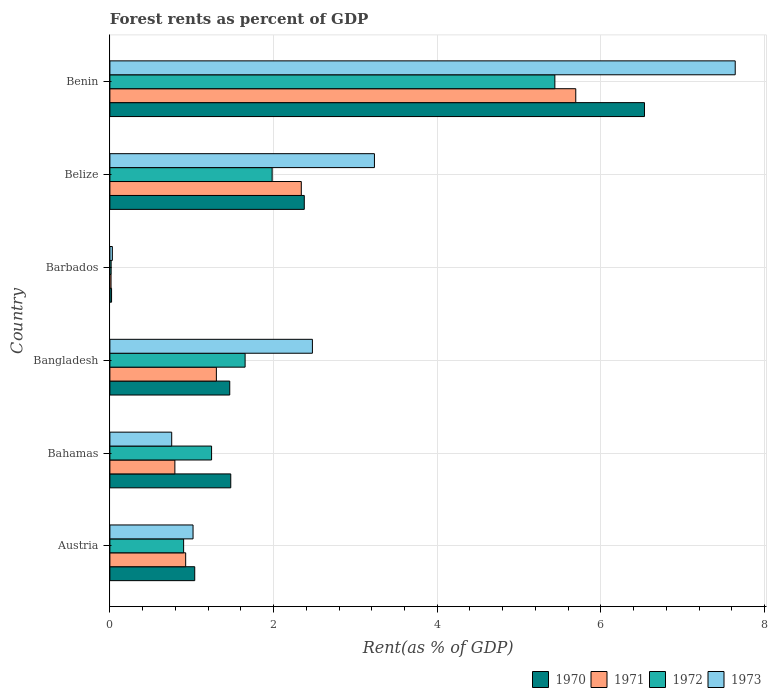How many different coloured bars are there?
Your answer should be compact. 4. Are the number of bars per tick equal to the number of legend labels?
Ensure brevity in your answer.  Yes. Are the number of bars on each tick of the Y-axis equal?
Ensure brevity in your answer.  Yes. What is the label of the 5th group of bars from the top?
Your answer should be compact. Bahamas. In how many cases, is the number of bars for a given country not equal to the number of legend labels?
Provide a short and direct response. 0. What is the forest rent in 1971 in Austria?
Your answer should be very brief. 0.93. Across all countries, what is the maximum forest rent in 1972?
Make the answer very short. 5.44. Across all countries, what is the minimum forest rent in 1972?
Offer a very short reply. 0.02. In which country was the forest rent in 1973 maximum?
Give a very brief answer. Benin. In which country was the forest rent in 1970 minimum?
Offer a terse response. Barbados. What is the total forest rent in 1970 in the graph?
Offer a very short reply. 12.91. What is the difference between the forest rent in 1973 in Austria and that in Bangladesh?
Provide a short and direct response. -1.46. What is the difference between the forest rent in 1973 in Austria and the forest rent in 1972 in Barbados?
Your response must be concise. 1. What is the average forest rent in 1973 per country?
Make the answer very short. 2.52. What is the difference between the forest rent in 1970 and forest rent in 1972 in Bahamas?
Make the answer very short. 0.23. In how many countries, is the forest rent in 1973 greater than 2.4 %?
Ensure brevity in your answer.  3. What is the ratio of the forest rent in 1972 in Barbados to that in Belize?
Ensure brevity in your answer.  0.01. Is the forest rent in 1972 in Bahamas less than that in Bangladesh?
Your response must be concise. Yes. What is the difference between the highest and the second highest forest rent in 1970?
Your answer should be very brief. 4.16. What is the difference between the highest and the lowest forest rent in 1970?
Offer a terse response. 6.51. Is the sum of the forest rent in 1971 in Bangladesh and Barbados greater than the maximum forest rent in 1970 across all countries?
Give a very brief answer. No. Is it the case that in every country, the sum of the forest rent in 1973 and forest rent in 1971 is greater than the sum of forest rent in 1970 and forest rent in 1972?
Give a very brief answer. No. How many countries are there in the graph?
Your response must be concise. 6. Where does the legend appear in the graph?
Provide a short and direct response. Bottom right. How many legend labels are there?
Keep it short and to the point. 4. How are the legend labels stacked?
Offer a very short reply. Horizontal. What is the title of the graph?
Your response must be concise. Forest rents as percent of GDP. What is the label or title of the X-axis?
Ensure brevity in your answer.  Rent(as % of GDP). What is the Rent(as % of GDP) in 1970 in Austria?
Provide a succinct answer. 1.04. What is the Rent(as % of GDP) of 1971 in Austria?
Keep it short and to the point. 0.93. What is the Rent(as % of GDP) of 1972 in Austria?
Provide a succinct answer. 0.9. What is the Rent(as % of GDP) of 1973 in Austria?
Offer a very short reply. 1.02. What is the Rent(as % of GDP) in 1970 in Bahamas?
Provide a short and direct response. 1.48. What is the Rent(as % of GDP) of 1971 in Bahamas?
Ensure brevity in your answer.  0.79. What is the Rent(as % of GDP) of 1972 in Bahamas?
Your response must be concise. 1.24. What is the Rent(as % of GDP) of 1973 in Bahamas?
Your response must be concise. 0.76. What is the Rent(as % of GDP) in 1970 in Bangladesh?
Make the answer very short. 1.46. What is the Rent(as % of GDP) in 1971 in Bangladesh?
Keep it short and to the point. 1.3. What is the Rent(as % of GDP) in 1972 in Bangladesh?
Give a very brief answer. 1.65. What is the Rent(as % of GDP) of 1973 in Bangladesh?
Your answer should be compact. 2.47. What is the Rent(as % of GDP) in 1970 in Barbados?
Offer a very short reply. 0.02. What is the Rent(as % of GDP) of 1971 in Barbados?
Make the answer very short. 0.01. What is the Rent(as % of GDP) of 1972 in Barbados?
Offer a very short reply. 0.02. What is the Rent(as % of GDP) of 1973 in Barbados?
Provide a succinct answer. 0.03. What is the Rent(as % of GDP) in 1970 in Belize?
Ensure brevity in your answer.  2.38. What is the Rent(as % of GDP) of 1971 in Belize?
Your answer should be very brief. 2.34. What is the Rent(as % of GDP) in 1972 in Belize?
Offer a very short reply. 1.98. What is the Rent(as % of GDP) in 1973 in Belize?
Give a very brief answer. 3.23. What is the Rent(as % of GDP) in 1970 in Benin?
Offer a terse response. 6.53. What is the Rent(as % of GDP) in 1971 in Benin?
Offer a very short reply. 5.69. What is the Rent(as % of GDP) in 1972 in Benin?
Offer a terse response. 5.44. What is the Rent(as % of GDP) in 1973 in Benin?
Keep it short and to the point. 7.64. Across all countries, what is the maximum Rent(as % of GDP) of 1970?
Provide a succinct answer. 6.53. Across all countries, what is the maximum Rent(as % of GDP) in 1971?
Your answer should be very brief. 5.69. Across all countries, what is the maximum Rent(as % of GDP) of 1972?
Keep it short and to the point. 5.44. Across all countries, what is the maximum Rent(as % of GDP) in 1973?
Your answer should be compact. 7.64. Across all countries, what is the minimum Rent(as % of GDP) of 1970?
Ensure brevity in your answer.  0.02. Across all countries, what is the minimum Rent(as % of GDP) of 1971?
Make the answer very short. 0.01. Across all countries, what is the minimum Rent(as % of GDP) of 1972?
Your response must be concise. 0.02. Across all countries, what is the minimum Rent(as % of GDP) in 1973?
Ensure brevity in your answer.  0.03. What is the total Rent(as % of GDP) in 1970 in the graph?
Give a very brief answer. 12.91. What is the total Rent(as % of GDP) of 1971 in the graph?
Give a very brief answer. 11.07. What is the total Rent(as % of GDP) of 1972 in the graph?
Ensure brevity in your answer.  11.23. What is the total Rent(as % of GDP) of 1973 in the graph?
Keep it short and to the point. 15.15. What is the difference between the Rent(as % of GDP) in 1970 in Austria and that in Bahamas?
Give a very brief answer. -0.44. What is the difference between the Rent(as % of GDP) of 1971 in Austria and that in Bahamas?
Provide a short and direct response. 0.13. What is the difference between the Rent(as % of GDP) in 1972 in Austria and that in Bahamas?
Provide a short and direct response. -0.34. What is the difference between the Rent(as % of GDP) in 1973 in Austria and that in Bahamas?
Your answer should be very brief. 0.26. What is the difference between the Rent(as % of GDP) in 1970 in Austria and that in Bangladesh?
Keep it short and to the point. -0.43. What is the difference between the Rent(as % of GDP) of 1971 in Austria and that in Bangladesh?
Provide a succinct answer. -0.38. What is the difference between the Rent(as % of GDP) in 1972 in Austria and that in Bangladesh?
Provide a short and direct response. -0.75. What is the difference between the Rent(as % of GDP) in 1973 in Austria and that in Bangladesh?
Ensure brevity in your answer.  -1.46. What is the difference between the Rent(as % of GDP) in 1970 in Austria and that in Barbados?
Offer a very short reply. 1.02. What is the difference between the Rent(as % of GDP) of 1971 in Austria and that in Barbados?
Your answer should be very brief. 0.91. What is the difference between the Rent(as % of GDP) of 1972 in Austria and that in Barbados?
Keep it short and to the point. 0.89. What is the difference between the Rent(as % of GDP) of 1973 in Austria and that in Barbados?
Provide a short and direct response. 0.99. What is the difference between the Rent(as % of GDP) in 1970 in Austria and that in Belize?
Keep it short and to the point. -1.34. What is the difference between the Rent(as % of GDP) of 1971 in Austria and that in Belize?
Provide a short and direct response. -1.41. What is the difference between the Rent(as % of GDP) of 1972 in Austria and that in Belize?
Give a very brief answer. -1.08. What is the difference between the Rent(as % of GDP) of 1973 in Austria and that in Belize?
Offer a terse response. -2.22. What is the difference between the Rent(as % of GDP) in 1970 in Austria and that in Benin?
Offer a very short reply. -5.5. What is the difference between the Rent(as % of GDP) in 1971 in Austria and that in Benin?
Make the answer very short. -4.77. What is the difference between the Rent(as % of GDP) in 1972 in Austria and that in Benin?
Ensure brevity in your answer.  -4.54. What is the difference between the Rent(as % of GDP) of 1973 in Austria and that in Benin?
Keep it short and to the point. -6.62. What is the difference between the Rent(as % of GDP) of 1970 in Bahamas and that in Bangladesh?
Give a very brief answer. 0.01. What is the difference between the Rent(as % of GDP) in 1971 in Bahamas and that in Bangladesh?
Offer a terse response. -0.51. What is the difference between the Rent(as % of GDP) in 1972 in Bahamas and that in Bangladesh?
Ensure brevity in your answer.  -0.41. What is the difference between the Rent(as % of GDP) in 1973 in Bahamas and that in Bangladesh?
Give a very brief answer. -1.72. What is the difference between the Rent(as % of GDP) in 1970 in Bahamas and that in Barbados?
Ensure brevity in your answer.  1.46. What is the difference between the Rent(as % of GDP) in 1971 in Bahamas and that in Barbados?
Give a very brief answer. 0.78. What is the difference between the Rent(as % of GDP) in 1972 in Bahamas and that in Barbados?
Ensure brevity in your answer.  1.23. What is the difference between the Rent(as % of GDP) in 1973 in Bahamas and that in Barbados?
Make the answer very short. 0.73. What is the difference between the Rent(as % of GDP) in 1970 in Bahamas and that in Belize?
Offer a very short reply. -0.9. What is the difference between the Rent(as % of GDP) in 1971 in Bahamas and that in Belize?
Keep it short and to the point. -1.54. What is the difference between the Rent(as % of GDP) in 1972 in Bahamas and that in Belize?
Give a very brief answer. -0.74. What is the difference between the Rent(as % of GDP) in 1973 in Bahamas and that in Belize?
Provide a succinct answer. -2.48. What is the difference between the Rent(as % of GDP) in 1970 in Bahamas and that in Benin?
Provide a short and direct response. -5.06. What is the difference between the Rent(as % of GDP) in 1971 in Bahamas and that in Benin?
Your answer should be very brief. -4.9. What is the difference between the Rent(as % of GDP) in 1972 in Bahamas and that in Benin?
Your response must be concise. -4.19. What is the difference between the Rent(as % of GDP) of 1973 in Bahamas and that in Benin?
Ensure brevity in your answer.  -6.89. What is the difference between the Rent(as % of GDP) in 1970 in Bangladesh and that in Barbados?
Offer a very short reply. 1.44. What is the difference between the Rent(as % of GDP) of 1971 in Bangladesh and that in Barbados?
Ensure brevity in your answer.  1.29. What is the difference between the Rent(as % of GDP) of 1972 in Bangladesh and that in Barbados?
Give a very brief answer. 1.64. What is the difference between the Rent(as % of GDP) in 1973 in Bangladesh and that in Barbados?
Provide a succinct answer. 2.44. What is the difference between the Rent(as % of GDP) of 1970 in Bangladesh and that in Belize?
Make the answer very short. -0.91. What is the difference between the Rent(as % of GDP) of 1971 in Bangladesh and that in Belize?
Provide a succinct answer. -1.04. What is the difference between the Rent(as % of GDP) in 1972 in Bangladesh and that in Belize?
Provide a succinct answer. -0.33. What is the difference between the Rent(as % of GDP) in 1973 in Bangladesh and that in Belize?
Make the answer very short. -0.76. What is the difference between the Rent(as % of GDP) in 1970 in Bangladesh and that in Benin?
Keep it short and to the point. -5.07. What is the difference between the Rent(as % of GDP) in 1971 in Bangladesh and that in Benin?
Your answer should be very brief. -4.39. What is the difference between the Rent(as % of GDP) of 1972 in Bangladesh and that in Benin?
Your answer should be very brief. -3.79. What is the difference between the Rent(as % of GDP) in 1973 in Bangladesh and that in Benin?
Your answer should be very brief. -5.17. What is the difference between the Rent(as % of GDP) of 1970 in Barbados and that in Belize?
Your answer should be very brief. -2.35. What is the difference between the Rent(as % of GDP) of 1971 in Barbados and that in Belize?
Give a very brief answer. -2.32. What is the difference between the Rent(as % of GDP) of 1972 in Barbados and that in Belize?
Provide a succinct answer. -1.97. What is the difference between the Rent(as % of GDP) in 1973 in Barbados and that in Belize?
Provide a short and direct response. -3.2. What is the difference between the Rent(as % of GDP) in 1970 in Barbados and that in Benin?
Keep it short and to the point. -6.51. What is the difference between the Rent(as % of GDP) in 1971 in Barbados and that in Benin?
Keep it short and to the point. -5.68. What is the difference between the Rent(as % of GDP) in 1972 in Barbados and that in Benin?
Provide a short and direct response. -5.42. What is the difference between the Rent(as % of GDP) of 1973 in Barbados and that in Benin?
Provide a succinct answer. -7.61. What is the difference between the Rent(as % of GDP) of 1970 in Belize and that in Benin?
Provide a succinct answer. -4.16. What is the difference between the Rent(as % of GDP) in 1971 in Belize and that in Benin?
Offer a terse response. -3.35. What is the difference between the Rent(as % of GDP) of 1972 in Belize and that in Benin?
Your response must be concise. -3.45. What is the difference between the Rent(as % of GDP) of 1973 in Belize and that in Benin?
Your response must be concise. -4.41. What is the difference between the Rent(as % of GDP) in 1970 in Austria and the Rent(as % of GDP) in 1971 in Bahamas?
Your response must be concise. 0.24. What is the difference between the Rent(as % of GDP) of 1970 in Austria and the Rent(as % of GDP) of 1972 in Bahamas?
Keep it short and to the point. -0.21. What is the difference between the Rent(as % of GDP) in 1970 in Austria and the Rent(as % of GDP) in 1973 in Bahamas?
Offer a terse response. 0.28. What is the difference between the Rent(as % of GDP) of 1971 in Austria and the Rent(as % of GDP) of 1972 in Bahamas?
Your answer should be very brief. -0.32. What is the difference between the Rent(as % of GDP) in 1971 in Austria and the Rent(as % of GDP) in 1973 in Bahamas?
Offer a terse response. 0.17. What is the difference between the Rent(as % of GDP) of 1972 in Austria and the Rent(as % of GDP) of 1973 in Bahamas?
Your response must be concise. 0.15. What is the difference between the Rent(as % of GDP) of 1970 in Austria and the Rent(as % of GDP) of 1971 in Bangladesh?
Your answer should be compact. -0.26. What is the difference between the Rent(as % of GDP) in 1970 in Austria and the Rent(as % of GDP) in 1972 in Bangladesh?
Your answer should be compact. -0.62. What is the difference between the Rent(as % of GDP) of 1970 in Austria and the Rent(as % of GDP) of 1973 in Bangladesh?
Your answer should be very brief. -1.44. What is the difference between the Rent(as % of GDP) in 1971 in Austria and the Rent(as % of GDP) in 1972 in Bangladesh?
Your answer should be very brief. -0.73. What is the difference between the Rent(as % of GDP) of 1971 in Austria and the Rent(as % of GDP) of 1973 in Bangladesh?
Give a very brief answer. -1.55. What is the difference between the Rent(as % of GDP) in 1972 in Austria and the Rent(as % of GDP) in 1973 in Bangladesh?
Provide a succinct answer. -1.57. What is the difference between the Rent(as % of GDP) in 1970 in Austria and the Rent(as % of GDP) in 1971 in Barbados?
Your answer should be compact. 1.02. What is the difference between the Rent(as % of GDP) in 1970 in Austria and the Rent(as % of GDP) in 1972 in Barbados?
Provide a succinct answer. 1.02. What is the difference between the Rent(as % of GDP) of 1970 in Austria and the Rent(as % of GDP) of 1973 in Barbados?
Offer a terse response. 1.01. What is the difference between the Rent(as % of GDP) of 1971 in Austria and the Rent(as % of GDP) of 1972 in Barbados?
Offer a terse response. 0.91. What is the difference between the Rent(as % of GDP) in 1971 in Austria and the Rent(as % of GDP) in 1973 in Barbados?
Provide a succinct answer. 0.9. What is the difference between the Rent(as % of GDP) of 1972 in Austria and the Rent(as % of GDP) of 1973 in Barbados?
Offer a very short reply. 0.87. What is the difference between the Rent(as % of GDP) of 1970 in Austria and the Rent(as % of GDP) of 1971 in Belize?
Offer a very short reply. -1.3. What is the difference between the Rent(as % of GDP) of 1970 in Austria and the Rent(as % of GDP) of 1972 in Belize?
Give a very brief answer. -0.95. What is the difference between the Rent(as % of GDP) of 1970 in Austria and the Rent(as % of GDP) of 1973 in Belize?
Offer a very short reply. -2.2. What is the difference between the Rent(as % of GDP) of 1971 in Austria and the Rent(as % of GDP) of 1972 in Belize?
Offer a terse response. -1.06. What is the difference between the Rent(as % of GDP) of 1971 in Austria and the Rent(as % of GDP) of 1973 in Belize?
Your response must be concise. -2.31. What is the difference between the Rent(as % of GDP) of 1972 in Austria and the Rent(as % of GDP) of 1973 in Belize?
Provide a succinct answer. -2.33. What is the difference between the Rent(as % of GDP) of 1970 in Austria and the Rent(as % of GDP) of 1971 in Benin?
Ensure brevity in your answer.  -4.66. What is the difference between the Rent(as % of GDP) in 1970 in Austria and the Rent(as % of GDP) in 1972 in Benin?
Provide a short and direct response. -4.4. What is the difference between the Rent(as % of GDP) of 1970 in Austria and the Rent(as % of GDP) of 1973 in Benin?
Offer a terse response. -6.6. What is the difference between the Rent(as % of GDP) in 1971 in Austria and the Rent(as % of GDP) in 1972 in Benin?
Provide a short and direct response. -4.51. What is the difference between the Rent(as % of GDP) of 1971 in Austria and the Rent(as % of GDP) of 1973 in Benin?
Make the answer very short. -6.71. What is the difference between the Rent(as % of GDP) in 1972 in Austria and the Rent(as % of GDP) in 1973 in Benin?
Ensure brevity in your answer.  -6.74. What is the difference between the Rent(as % of GDP) in 1970 in Bahamas and the Rent(as % of GDP) in 1971 in Bangladesh?
Give a very brief answer. 0.18. What is the difference between the Rent(as % of GDP) in 1970 in Bahamas and the Rent(as % of GDP) in 1972 in Bangladesh?
Give a very brief answer. -0.18. What is the difference between the Rent(as % of GDP) in 1970 in Bahamas and the Rent(as % of GDP) in 1973 in Bangladesh?
Your response must be concise. -1. What is the difference between the Rent(as % of GDP) of 1971 in Bahamas and the Rent(as % of GDP) of 1972 in Bangladesh?
Your response must be concise. -0.86. What is the difference between the Rent(as % of GDP) of 1971 in Bahamas and the Rent(as % of GDP) of 1973 in Bangladesh?
Your response must be concise. -1.68. What is the difference between the Rent(as % of GDP) of 1972 in Bahamas and the Rent(as % of GDP) of 1973 in Bangladesh?
Keep it short and to the point. -1.23. What is the difference between the Rent(as % of GDP) in 1970 in Bahamas and the Rent(as % of GDP) in 1971 in Barbados?
Your answer should be compact. 1.46. What is the difference between the Rent(as % of GDP) in 1970 in Bahamas and the Rent(as % of GDP) in 1972 in Barbados?
Offer a terse response. 1.46. What is the difference between the Rent(as % of GDP) in 1970 in Bahamas and the Rent(as % of GDP) in 1973 in Barbados?
Provide a short and direct response. 1.45. What is the difference between the Rent(as % of GDP) in 1971 in Bahamas and the Rent(as % of GDP) in 1972 in Barbados?
Your response must be concise. 0.78. What is the difference between the Rent(as % of GDP) of 1971 in Bahamas and the Rent(as % of GDP) of 1973 in Barbados?
Give a very brief answer. 0.76. What is the difference between the Rent(as % of GDP) in 1972 in Bahamas and the Rent(as % of GDP) in 1973 in Barbados?
Your response must be concise. 1.21. What is the difference between the Rent(as % of GDP) in 1970 in Bahamas and the Rent(as % of GDP) in 1971 in Belize?
Your answer should be compact. -0.86. What is the difference between the Rent(as % of GDP) in 1970 in Bahamas and the Rent(as % of GDP) in 1972 in Belize?
Your response must be concise. -0.51. What is the difference between the Rent(as % of GDP) of 1970 in Bahamas and the Rent(as % of GDP) of 1973 in Belize?
Your answer should be compact. -1.76. What is the difference between the Rent(as % of GDP) in 1971 in Bahamas and the Rent(as % of GDP) in 1972 in Belize?
Provide a short and direct response. -1.19. What is the difference between the Rent(as % of GDP) of 1971 in Bahamas and the Rent(as % of GDP) of 1973 in Belize?
Keep it short and to the point. -2.44. What is the difference between the Rent(as % of GDP) of 1972 in Bahamas and the Rent(as % of GDP) of 1973 in Belize?
Your answer should be compact. -1.99. What is the difference between the Rent(as % of GDP) of 1970 in Bahamas and the Rent(as % of GDP) of 1971 in Benin?
Your answer should be compact. -4.22. What is the difference between the Rent(as % of GDP) of 1970 in Bahamas and the Rent(as % of GDP) of 1972 in Benin?
Offer a terse response. -3.96. What is the difference between the Rent(as % of GDP) of 1970 in Bahamas and the Rent(as % of GDP) of 1973 in Benin?
Your response must be concise. -6.16. What is the difference between the Rent(as % of GDP) in 1971 in Bahamas and the Rent(as % of GDP) in 1972 in Benin?
Your answer should be compact. -4.64. What is the difference between the Rent(as % of GDP) of 1971 in Bahamas and the Rent(as % of GDP) of 1973 in Benin?
Make the answer very short. -6.85. What is the difference between the Rent(as % of GDP) in 1972 in Bahamas and the Rent(as % of GDP) in 1973 in Benin?
Your answer should be compact. -6.4. What is the difference between the Rent(as % of GDP) in 1970 in Bangladesh and the Rent(as % of GDP) in 1971 in Barbados?
Your answer should be very brief. 1.45. What is the difference between the Rent(as % of GDP) in 1970 in Bangladesh and the Rent(as % of GDP) in 1972 in Barbados?
Your answer should be compact. 1.45. What is the difference between the Rent(as % of GDP) in 1970 in Bangladesh and the Rent(as % of GDP) in 1973 in Barbados?
Make the answer very short. 1.43. What is the difference between the Rent(as % of GDP) of 1971 in Bangladesh and the Rent(as % of GDP) of 1972 in Barbados?
Keep it short and to the point. 1.29. What is the difference between the Rent(as % of GDP) in 1971 in Bangladesh and the Rent(as % of GDP) in 1973 in Barbados?
Provide a succinct answer. 1.27. What is the difference between the Rent(as % of GDP) in 1972 in Bangladesh and the Rent(as % of GDP) in 1973 in Barbados?
Make the answer very short. 1.62. What is the difference between the Rent(as % of GDP) of 1970 in Bangladesh and the Rent(as % of GDP) of 1971 in Belize?
Make the answer very short. -0.87. What is the difference between the Rent(as % of GDP) in 1970 in Bangladesh and the Rent(as % of GDP) in 1972 in Belize?
Provide a short and direct response. -0.52. What is the difference between the Rent(as % of GDP) of 1970 in Bangladesh and the Rent(as % of GDP) of 1973 in Belize?
Make the answer very short. -1.77. What is the difference between the Rent(as % of GDP) of 1971 in Bangladesh and the Rent(as % of GDP) of 1972 in Belize?
Make the answer very short. -0.68. What is the difference between the Rent(as % of GDP) of 1971 in Bangladesh and the Rent(as % of GDP) of 1973 in Belize?
Offer a very short reply. -1.93. What is the difference between the Rent(as % of GDP) in 1972 in Bangladesh and the Rent(as % of GDP) in 1973 in Belize?
Provide a short and direct response. -1.58. What is the difference between the Rent(as % of GDP) of 1970 in Bangladesh and the Rent(as % of GDP) of 1971 in Benin?
Your answer should be very brief. -4.23. What is the difference between the Rent(as % of GDP) in 1970 in Bangladesh and the Rent(as % of GDP) in 1972 in Benin?
Your response must be concise. -3.97. What is the difference between the Rent(as % of GDP) in 1970 in Bangladesh and the Rent(as % of GDP) in 1973 in Benin?
Ensure brevity in your answer.  -6.18. What is the difference between the Rent(as % of GDP) of 1971 in Bangladesh and the Rent(as % of GDP) of 1972 in Benin?
Your answer should be very brief. -4.14. What is the difference between the Rent(as % of GDP) of 1971 in Bangladesh and the Rent(as % of GDP) of 1973 in Benin?
Provide a succinct answer. -6.34. What is the difference between the Rent(as % of GDP) in 1972 in Bangladesh and the Rent(as % of GDP) in 1973 in Benin?
Provide a succinct answer. -5.99. What is the difference between the Rent(as % of GDP) in 1970 in Barbados and the Rent(as % of GDP) in 1971 in Belize?
Keep it short and to the point. -2.32. What is the difference between the Rent(as % of GDP) of 1970 in Barbados and the Rent(as % of GDP) of 1972 in Belize?
Make the answer very short. -1.96. What is the difference between the Rent(as % of GDP) of 1970 in Barbados and the Rent(as % of GDP) of 1973 in Belize?
Make the answer very short. -3.21. What is the difference between the Rent(as % of GDP) in 1971 in Barbados and the Rent(as % of GDP) in 1972 in Belize?
Offer a very short reply. -1.97. What is the difference between the Rent(as % of GDP) of 1971 in Barbados and the Rent(as % of GDP) of 1973 in Belize?
Give a very brief answer. -3.22. What is the difference between the Rent(as % of GDP) in 1972 in Barbados and the Rent(as % of GDP) in 1973 in Belize?
Your answer should be very brief. -3.22. What is the difference between the Rent(as % of GDP) in 1970 in Barbados and the Rent(as % of GDP) in 1971 in Benin?
Your answer should be very brief. -5.67. What is the difference between the Rent(as % of GDP) of 1970 in Barbados and the Rent(as % of GDP) of 1972 in Benin?
Your answer should be very brief. -5.42. What is the difference between the Rent(as % of GDP) in 1970 in Barbados and the Rent(as % of GDP) in 1973 in Benin?
Keep it short and to the point. -7.62. What is the difference between the Rent(as % of GDP) in 1971 in Barbados and the Rent(as % of GDP) in 1972 in Benin?
Keep it short and to the point. -5.42. What is the difference between the Rent(as % of GDP) of 1971 in Barbados and the Rent(as % of GDP) of 1973 in Benin?
Give a very brief answer. -7.63. What is the difference between the Rent(as % of GDP) in 1972 in Barbados and the Rent(as % of GDP) in 1973 in Benin?
Keep it short and to the point. -7.63. What is the difference between the Rent(as % of GDP) in 1970 in Belize and the Rent(as % of GDP) in 1971 in Benin?
Provide a succinct answer. -3.32. What is the difference between the Rent(as % of GDP) in 1970 in Belize and the Rent(as % of GDP) in 1972 in Benin?
Keep it short and to the point. -3.06. What is the difference between the Rent(as % of GDP) in 1970 in Belize and the Rent(as % of GDP) in 1973 in Benin?
Provide a succinct answer. -5.27. What is the difference between the Rent(as % of GDP) in 1971 in Belize and the Rent(as % of GDP) in 1972 in Benin?
Give a very brief answer. -3.1. What is the difference between the Rent(as % of GDP) in 1971 in Belize and the Rent(as % of GDP) in 1973 in Benin?
Ensure brevity in your answer.  -5.3. What is the difference between the Rent(as % of GDP) of 1972 in Belize and the Rent(as % of GDP) of 1973 in Benin?
Your answer should be compact. -5.66. What is the average Rent(as % of GDP) in 1970 per country?
Give a very brief answer. 2.15. What is the average Rent(as % of GDP) in 1971 per country?
Give a very brief answer. 1.84. What is the average Rent(as % of GDP) in 1972 per country?
Make the answer very short. 1.87. What is the average Rent(as % of GDP) of 1973 per country?
Make the answer very short. 2.52. What is the difference between the Rent(as % of GDP) in 1970 and Rent(as % of GDP) in 1971 in Austria?
Your response must be concise. 0.11. What is the difference between the Rent(as % of GDP) of 1970 and Rent(as % of GDP) of 1972 in Austria?
Ensure brevity in your answer.  0.14. What is the difference between the Rent(as % of GDP) in 1970 and Rent(as % of GDP) in 1973 in Austria?
Your answer should be very brief. 0.02. What is the difference between the Rent(as % of GDP) of 1971 and Rent(as % of GDP) of 1972 in Austria?
Ensure brevity in your answer.  0.03. What is the difference between the Rent(as % of GDP) of 1971 and Rent(as % of GDP) of 1973 in Austria?
Ensure brevity in your answer.  -0.09. What is the difference between the Rent(as % of GDP) of 1972 and Rent(as % of GDP) of 1973 in Austria?
Provide a succinct answer. -0.12. What is the difference between the Rent(as % of GDP) of 1970 and Rent(as % of GDP) of 1971 in Bahamas?
Your answer should be compact. 0.68. What is the difference between the Rent(as % of GDP) of 1970 and Rent(as % of GDP) of 1972 in Bahamas?
Your answer should be very brief. 0.23. What is the difference between the Rent(as % of GDP) of 1970 and Rent(as % of GDP) of 1973 in Bahamas?
Give a very brief answer. 0.72. What is the difference between the Rent(as % of GDP) in 1971 and Rent(as % of GDP) in 1972 in Bahamas?
Your answer should be very brief. -0.45. What is the difference between the Rent(as % of GDP) in 1971 and Rent(as % of GDP) in 1973 in Bahamas?
Provide a succinct answer. 0.04. What is the difference between the Rent(as % of GDP) in 1972 and Rent(as % of GDP) in 1973 in Bahamas?
Your answer should be compact. 0.49. What is the difference between the Rent(as % of GDP) of 1970 and Rent(as % of GDP) of 1971 in Bangladesh?
Ensure brevity in your answer.  0.16. What is the difference between the Rent(as % of GDP) in 1970 and Rent(as % of GDP) in 1972 in Bangladesh?
Your answer should be compact. -0.19. What is the difference between the Rent(as % of GDP) of 1970 and Rent(as % of GDP) of 1973 in Bangladesh?
Ensure brevity in your answer.  -1.01. What is the difference between the Rent(as % of GDP) of 1971 and Rent(as % of GDP) of 1972 in Bangladesh?
Make the answer very short. -0.35. What is the difference between the Rent(as % of GDP) of 1971 and Rent(as % of GDP) of 1973 in Bangladesh?
Give a very brief answer. -1.17. What is the difference between the Rent(as % of GDP) in 1972 and Rent(as % of GDP) in 1973 in Bangladesh?
Your answer should be very brief. -0.82. What is the difference between the Rent(as % of GDP) of 1970 and Rent(as % of GDP) of 1971 in Barbados?
Provide a short and direct response. 0.01. What is the difference between the Rent(as % of GDP) of 1970 and Rent(as % of GDP) of 1972 in Barbados?
Keep it short and to the point. 0.01. What is the difference between the Rent(as % of GDP) in 1970 and Rent(as % of GDP) in 1973 in Barbados?
Provide a succinct answer. -0.01. What is the difference between the Rent(as % of GDP) of 1971 and Rent(as % of GDP) of 1972 in Barbados?
Give a very brief answer. -0. What is the difference between the Rent(as % of GDP) of 1971 and Rent(as % of GDP) of 1973 in Barbados?
Your answer should be very brief. -0.02. What is the difference between the Rent(as % of GDP) in 1972 and Rent(as % of GDP) in 1973 in Barbados?
Your response must be concise. -0.01. What is the difference between the Rent(as % of GDP) in 1970 and Rent(as % of GDP) in 1971 in Belize?
Your response must be concise. 0.04. What is the difference between the Rent(as % of GDP) in 1970 and Rent(as % of GDP) in 1972 in Belize?
Provide a succinct answer. 0.39. What is the difference between the Rent(as % of GDP) of 1970 and Rent(as % of GDP) of 1973 in Belize?
Provide a succinct answer. -0.86. What is the difference between the Rent(as % of GDP) in 1971 and Rent(as % of GDP) in 1972 in Belize?
Your answer should be compact. 0.36. What is the difference between the Rent(as % of GDP) in 1971 and Rent(as % of GDP) in 1973 in Belize?
Offer a very short reply. -0.89. What is the difference between the Rent(as % of GDP) in 1972 and Rent(as % of GDP) in 1973 in Belize?
Provide a short and direct response. -1.25. What is the difference between the Rent(as % of GDP) of 1970 and Rent(as % of GDP) of 1971 in Benin?
Offer a terse response. 0.84. What is the difference between the Rent(as % of GDP) in 1970 and Rent(as % of GDP) in 1972 in Benin?
Provide a short and direct response. 1.09. What is the difference between the Rent(as % of GDP) in 1970 and Rent(as % of GDP) in 1973 in Benin?
Offer a terse response. -1.11. What is the difference between the Rent(as % of GDP) in 1971 and Rent(as % of GDP) in 1972 in Benin?
Your answer should be very brief. 0.26. What is the difference between the Rent(as % of GDP) of 1971 and Rent(as % of GDP) of 1973 in Benin?
Make the answer very short. -1.95. What is the difference between the Rent(as % of GDP) of 1972 and Rent(as % of GDP) of 1973 in Benin?
Ensure brevity in your answer.  -2.2. What is the ratio of the Rent(as % of GDP) in 1970 in Austria to that in Bahamas?
Keep it short and to the point. 0.7. What is the ratio of the Rent(as % of GDP) of 1971 in Austria to that in Bahamas?
Ensure brevity in your answer.  1.17. What is the ratio of the Rent(as % of GDP) in 1972 in Austria to that in Bahamas?
Offer a very short reply. 0.72. What is the ratio of the Rent(as % of GDP) in 1973 in Austria to that in Bahamas?
Provide a succinct answer. 1.35. What is the ratio of the Rent(as % of GDP) in 1970 in Austria to that in Bangladesh?
Your answer should be compact. 0.71. What is the ratio of the Rent(as % of GDP) of 1971 in Austria to that in Bangladesh?
Keep it short and to the point. 0.71. What is the ratio of the Rent(as % of GDP) in 1972 in Austria to that in Bangladesh?
Offer a very short reply. 0.55. What is the ratio of the Rent(as % of GDP) in 1973 in Austria to that in Bangladesh?
Offer a very short reply. 0.41. What is the ratio of the Rent(as % of GDP) of 1970 in Austria to that in Barbados?
Keep it short and to the point. 50.82. What is the ratio of the Rent(as % of GDP) of 1971 in Austria to that in Barbados?
Your answer should be compact. 65.99. What is the ratio of the Rent(as % of GDP) of 1972 in Austria to that in Barbados?
Offer a very short reply. 58.93. What is the ratio of the Rent(as % of GDP) of 1973 in Austria to that in Barbados?
Offer a very short reply. 33.75. What is the ratio of the Rent(as % of GDP) in 1970 in Austria to that in Belize?
Give a very brief answer. 0.44. What is the ratio of the Rent(as % of GDP) of 1971 in Austria to that in Belize?
Your answer should be very brief. 0.4. What is the ratio of the Rent(as % of GDP) in 1972 in Austria to that in Belize?
Your answer should be very brief. 0.45. What is the ratio of the Rent(as % of GDP) of 1973 in Austria to that in Belize?
Provide a short and direct response. 0.31. What is the ratio of the Rent(as % of GDP) of 1970 in Austria to that in Benin?
Your response must be concise. 0.16. What is the ratio of the Rent(as % of GDP) in 1971 in Austria to that in Benin?
Make the answer very short. 0.16. What is the ratio of the Rent(as % of GDP) of 1972 in Austria to that in Benin?
Give a very brief answer. 0.17. What is the ratio of the Rent(as % of GDP) of 1973 in Austria to that in Benin?
Provide a succinct answer. 0.13. What is the ratio of the Rent(as % of GDP) of 1970 in Bahamas to that in Bangladesh?
Provide a succinct answer. 1.01. What is the ratio of the Rent(as % of GDP) in 1971 in Bahamas to that in Bangladesh?
Your response must be concise. 0.61. What is the ratio of the Rent(as % of GDP) of 1972 in Bahamas to that in Bangladesh?
Ensure brevity in your answer.  0.75. What is the ratio of the Rent(as % of GDP) of 1973 in Bahamas to that in Bangladesh?
Your answer should be very brief. 0.31. What is the ratio of the Rent(as % of GDP) in 1970 in Bahamas to that in Barbados?
Give a very brief answer. 72.4. What is the ratio of the Rent(as % of GDP) of 1971 in Bahamas to that in Barbados?
Keep it short and to the point. 56.58. What is the ratio of the Rent(as % of GDP) in 1972 in Bahamas to that in Barbados?
Give a very brief answer. 81.28. What is the ratio of the Rent(as % of GDP) in 1973 in Bahamas to that in Barbados?
Offer a very short reply. 25.08. What is the ratio of the Rent(as % of GDP) in 1970 in Bahamas to that in Belize?
Provide a succinct answer. 0.62. What is the ratio of the Rent(as % of GDP) in 1971 in Bahamas to that in Belize?
Give a very brief answer. 0.34. What is the ratio of the Rent(as % of GDP) of 1972 in Bahamas to that in Belize?
Give a very brief answer. 0.63. What is the ratio of the Rent(as % of GDP) in 1973 in Bahamas to that in Belize?
Give a very brief answer. 0.23. What is the ratio of the Rent(as % of GDP) in 1970 in Bahamas to that in Benin?
Make the answer very short. 0.23. What is the ratio of the Rent(as % of GDP) in 1971 in Bahamas to that in Benin?
Keep it short and to the point. 0.14. What is the ratio of the Rent(as % of GDP) in 1972 in Bahamas to that in Benin?
Offer a very short reply. 0.23. What is the ratio of the Rent(as % of GDP) in 1973 in Bahamas to that in Benin?
Provide a succinct answer. 0.1. What is the ratio of the Rent(as % of GDP) in 1970 in Bangladesh to that in Barbados?
Give a very brief answer. 71.79. What is the ratio of the Rent(as % of GDP) of 1971 in Bangladesh to that in Barbados?
Provide a short and direct response. 92.71. What is the ratio of the Rent(as % of GDP) of 1972 in Bangladesh to that in Barbados?
Ensure brevity in your answer.  108.07. What is the ratio of the Rent(as % of GDP) in 1973 in Bangladesh to that in Barbados?
Offer a terse response. 82.18. What is the ratio of the Rent(as % of GDP) in 1970 in Bangladesh to that in Belize?
Provide a succinct answer. 0.62. What is the ratio of the Rent(as % of GDP) in 1971 in Bangladesh to that in Belize?
Make the answer very short. 0.56. What is the ratio of the Rent(as % of GDP) in 1972 in Bangladesh to that in Belize?
Provide a succinct answer. 0.83. What is the ratio of the Rent(as % of GDP) in 1973 in Bangladesh to that in Belize?
Offer a terse response. 0.77. What is the ratio of the Rent(as % of GDP) in 1970 in Bangladesh to that in Benin?
Give a very brief answer. 0.22. What is the ratio of the Rent(as % of GDP) in 1971 in Bangladesh to that in Benin?
Your answer should be very brief. 0.23. What is the ratio of the Rent(as % of GDP) of 1972 in Bangladesh to that in Benin?
Your answer should be compact. 0.3. What is the ratio of the Rent(as % of GDP) in 1973 in Bangladesh to that in Benin?
Keep it short and to the point. 0.32. What is the ratio of the Rent(as % of GDP) in 1970 in Barbados to that in Belize?
Provide a succinct answer. 0.01. What is the ratio of the Rent(as % of GDP) of 1971 in Barbados to that in Belize?
Your answer should be compact. 0.01. What is the ratio of the Rent(as % of GDP) of 1972 in Barbados to that in Belize?
Keep it short and to the point. 0.01. What is the ratio of the Rent(as % of GDP) of 1973 in Barbados to that in Belize?
Offer a very short reply. 0.01. What is the ratio of the Rent(as % of GDP) of 1970 in Barbados to that in Benin?
Ensure brevity in your answer.  0. What is the ratio of the Rent(as % of GDP) of 1971 in Barbados to that in Benin?
Make the answer very short. 0. What is the ratio of the Rent(as % of GDP) in 1972 in Barbados to that in Benin?
Keep it short and to the point. 0. What is the ratio of the Rent(as % of GDP) of 1973 in Barbados to that in Benin?
Provide a short and direct response. 0. What is the ratio of the Rent(as % of GDP) of 1970 in Belize to that in Benin?
Make the answer very short. 0.36. What is the ratio of the Rent(as % of GDP) in 1971 in Belize to that in Benin?
Your response must be concise. 0.41. What is the ratio of the Rent(as % of GDP) in 1972 in Belize to that in Benin?
Keep it short and to the point. 0.36. What is the ratio of the Rent(as % of GDP) in 1973 in Belize to that in Benin?
Offer a very short reply. 0.42. What is the difference between the highest and the second highest Rent(as % of GDP) of 1970?
Keep it short and to the point. 4.16. What is the difference between the highest and the second highest Rent(as % of GDP) of 1971?
Offer a very short reply. 3.35. What is the difference between the highest and the second highest Rent(as % of GDP) in 1972?
Your response must be concise. 3.45. What is the difference between the highest and the second highest Rent(as % of GDP) of 1973?
Provide a succinct answer. 4.41. What is the difference between the highest and the lowest Rent(as % of GDP) of 1970?
Offer a terse response. 6.51. What is the difference between the highest and the lowest Rent(as % of GDP) of 1971?
Provide a short and direct response. 5.68. What is the difference between the highest and the lowest Rent(as % of GDP) of 1972?
Keep it short and to the point. 5.42. What is the difference between the highest and the lowest Rent(as % of GDP) in 1973?
Make the answer very short. 7.61. 